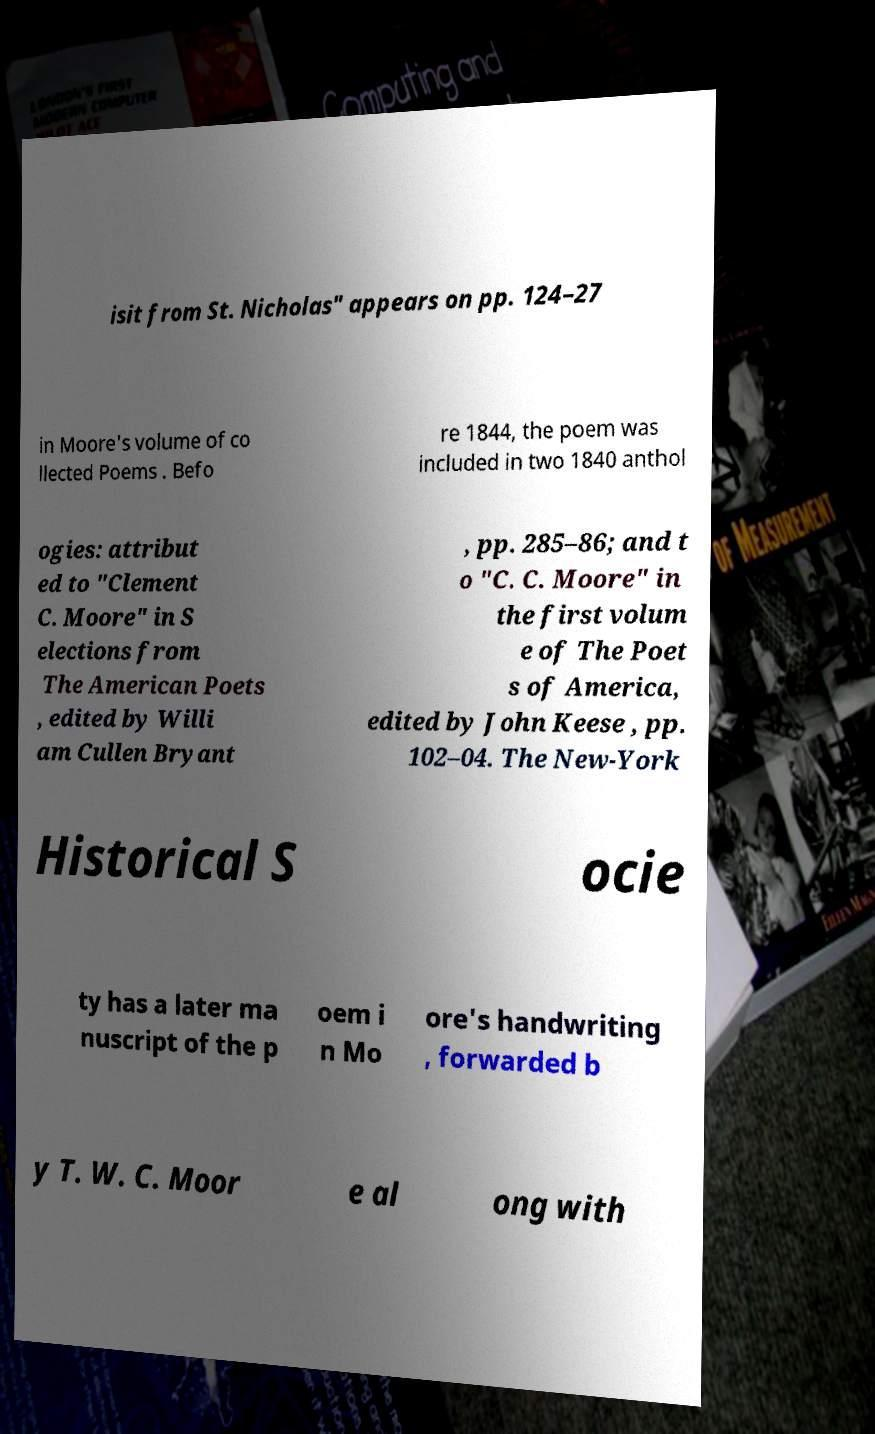Can you read and provide the text displayed in the image?This photo seems to have some interesting text. Can you extract and type it out for me? isit from St. Nicholas" appears on pp. 124–27 in Moore's volume of co llected Poems . Befo re 1844, the poem was included in two 1840 anthol ogies: attribut ed to "Clement C. Moore" in S elections from The American Poets , edited by Willi am Cullen Bryant , pp. 285–86; and t o "C. C. Moore" in the first volum e of The Poet s of America, edited by John Keese , pp. 102–04. The New-York Historical S ocie ty has a later ma nuscript of the p oem i n Mo ore's handwriting , forwarded b y T. W. C. Moor e al ong with 